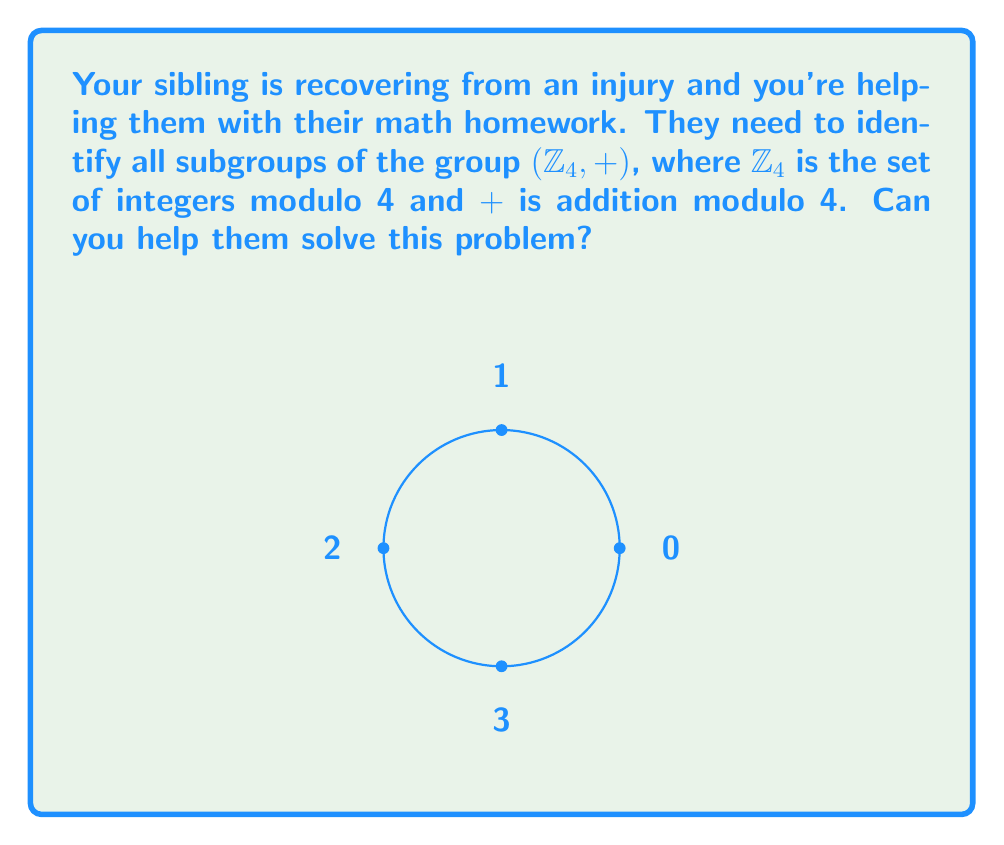Teach me how to tackle this problem. Let's approach this step-by-step:

1) First, recall that $\mathbb{Z}_4 = \{0, 1, 2, 3\}$.

2) To find all subgroups, we need to check which subsets of $\mathbb{Z}_4$ are closed under addition modulo 4 and contain the identity element (0).

3) The trivial subgroup $\{0\}$ is always a subgroup.

4) The entire group $\{0, 1, 2, 3\}$ is also always a subgroup.

5) Now, let's check other potential subgroups:
   
   a) $\{0, 1\}$: $1 + 1 \equiv 2 \pmod{4}$, so this is not closed.
   b) $\{0, 2\}$: $2 + 2 \equiv 0 \pmod{4}$, so this is closed. This is a subgroup.
   c) $\{0, 3\}$: $3 + 3 \equiv 2 \pmod{4}$, so this is not closed.
   d) $\{0, 1, 2\}$: Not closed as $1 + 2 \equiv 3 \pmod{4}$.
   e) $\{0, 1, 3\}$: Not closed as $1 + 3 \equiv 0 \pmod{4}$.
   f) $\{0, 2, 3\}$: Not closed as $2 + 3 \equiv 1 \pmod{4}$.

6) Therefore, we have found all subgroups of $(\mathbb{Z}_4, +)$.
Answer: $\{0\}$, $\{0,2\}$, $\{0,1,2,3\}$ 